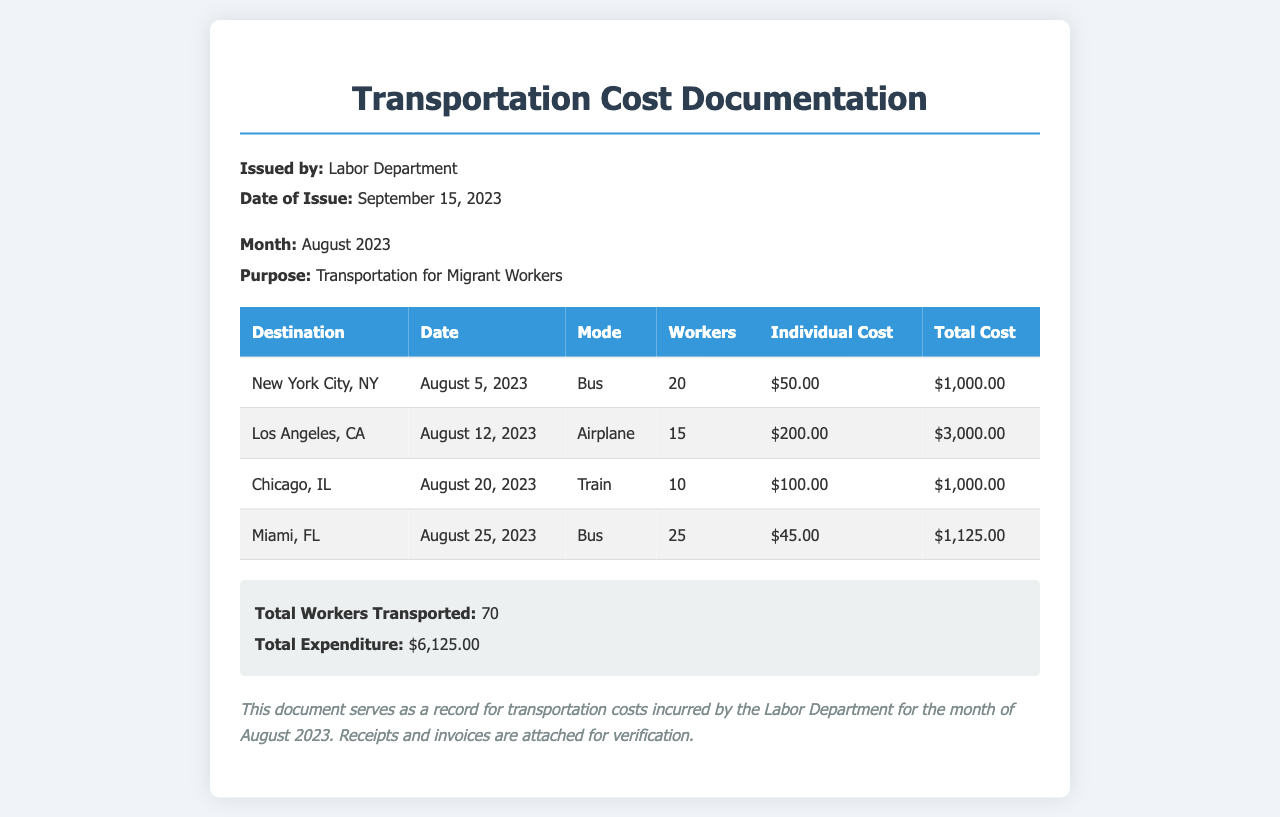what is the date of issue of the document? The date of issue is clearly stated in the document as September 15, 2023.
Answer: September 15, 2023 what is the total expenditure for August 2023? The total expenditure is mentioned in the summary section, which totals $6,125.00.
Answer: $6,125.00 how many workers were transported to Miami, FL? The number of workers transported to Miami, FL is listed as 25 in the table.
Answer: 25 which mode of transportation was used for the trip to Chicago, IL? The mode of transportation for Chicago, IL is specified as Train in the table.
Answer: Train what is the individual cost for transportation to New York City, NY? The individual cost for New York City, NY is detailed in the table as $50.00.
Answer: $50.00 what was the purpose of the transportation organized by the Labor Department? The purpose is indicated in the document as Transportation for Migrant Workers.
Answer: Transportation for Migrant Workers how many destinations are listed in the document? By counting the entries in the table, there are four destinations mentioned.
Answer: 4 what is the destination with the highest total cost? The destination with the highest total cost is Los Angeles, CA, with a total of $3,000.00.
Answer: Los Angeles, CA how many total workers were transported? The summary section indicates the total number of workers transported as 70.
Answer: 70 